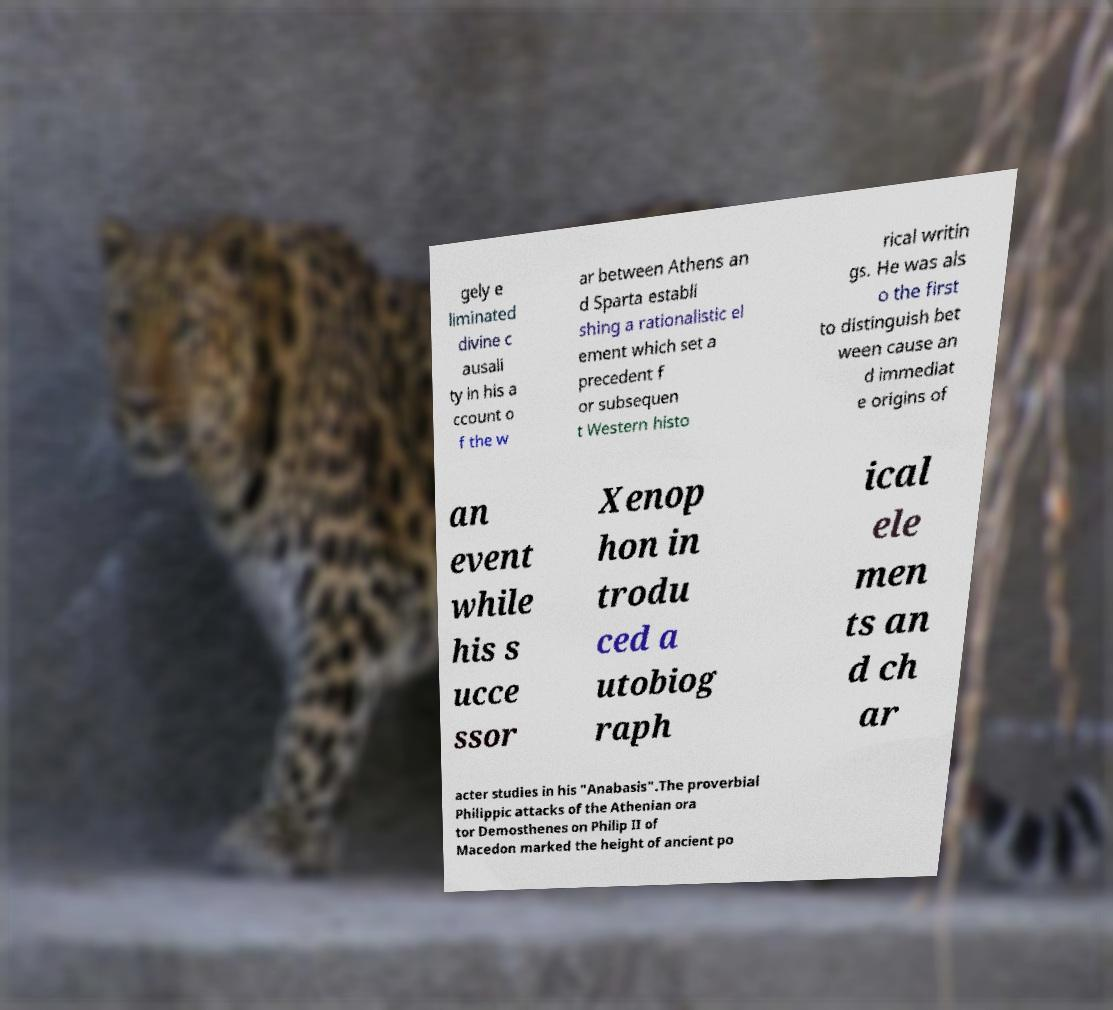Please read and relay the text visible in this image. What does it say? gely e liminated divine c ausali ty in his a ccount o f the w ar between Athens an d Sparta establi shing a rationalistic el ement which set a precedent f or subsequen t Western histo rical writin gs. He was als o the first to distinguish bet ween cause an d immediat e origins of an event while his s ucce ssor Xenop hon in trodu ced a utobiog raph ical ele men ts an d ch ar acter studies in his "Anabasis".The proverbial Philippic attacks of the Athenian ora tor Demosthenes on Philip II of Macedon marked the height of ancient po 